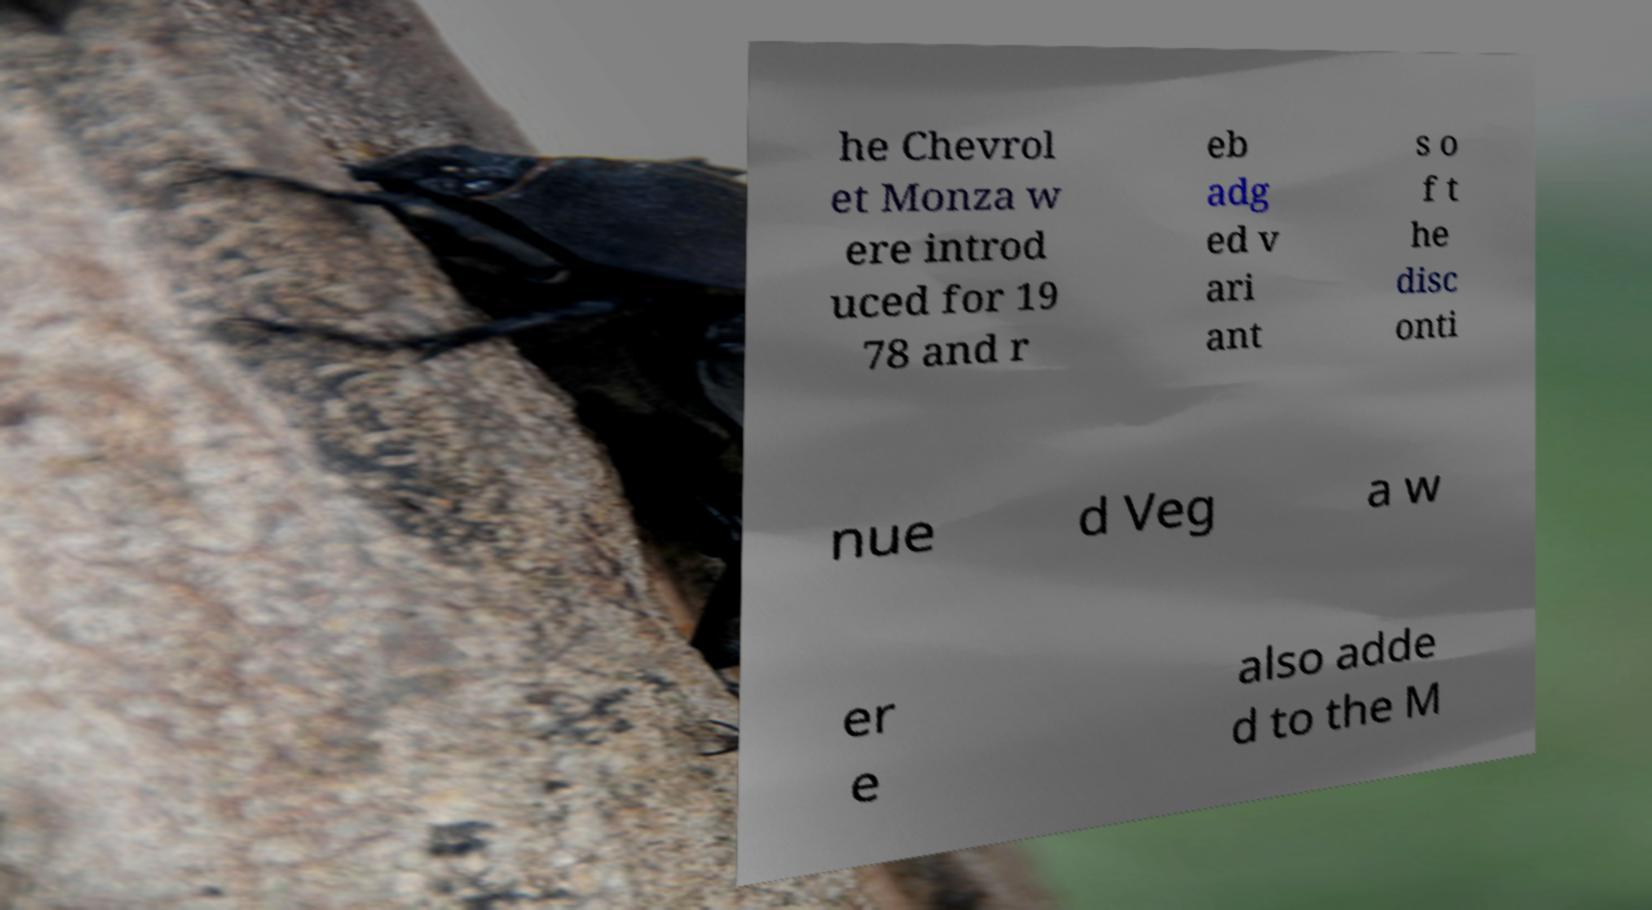Can you read and provide the text displayed in the image?This photo seems to have some interesting text. Can you extract and type it out for me? he Chevrol et Monza w ere introd uced for 19 78 and r eb adg ed v ari ant s o f t he disc onti nue d Veg a w er e also adde d to the M 